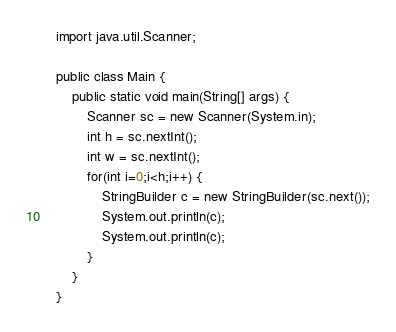Convert code to text. <code><loc_0><loc_0><loc_500><loc_500><_Java_>    import java.util.Scanner;

    public class Main {
    	public static void main(String[] args) {
    		Scanner sc = new Scanner(System.in);
    		int h = sc.nextInt();
    		int w = sc.nextInt();
    		for(int i=0;i<h;i++) {
    			StringBuilder c = new StringBuilder(sc.next());
    			System.out.println(c);
    			System.out.println(c);
    		}
    	}
    }</code> 